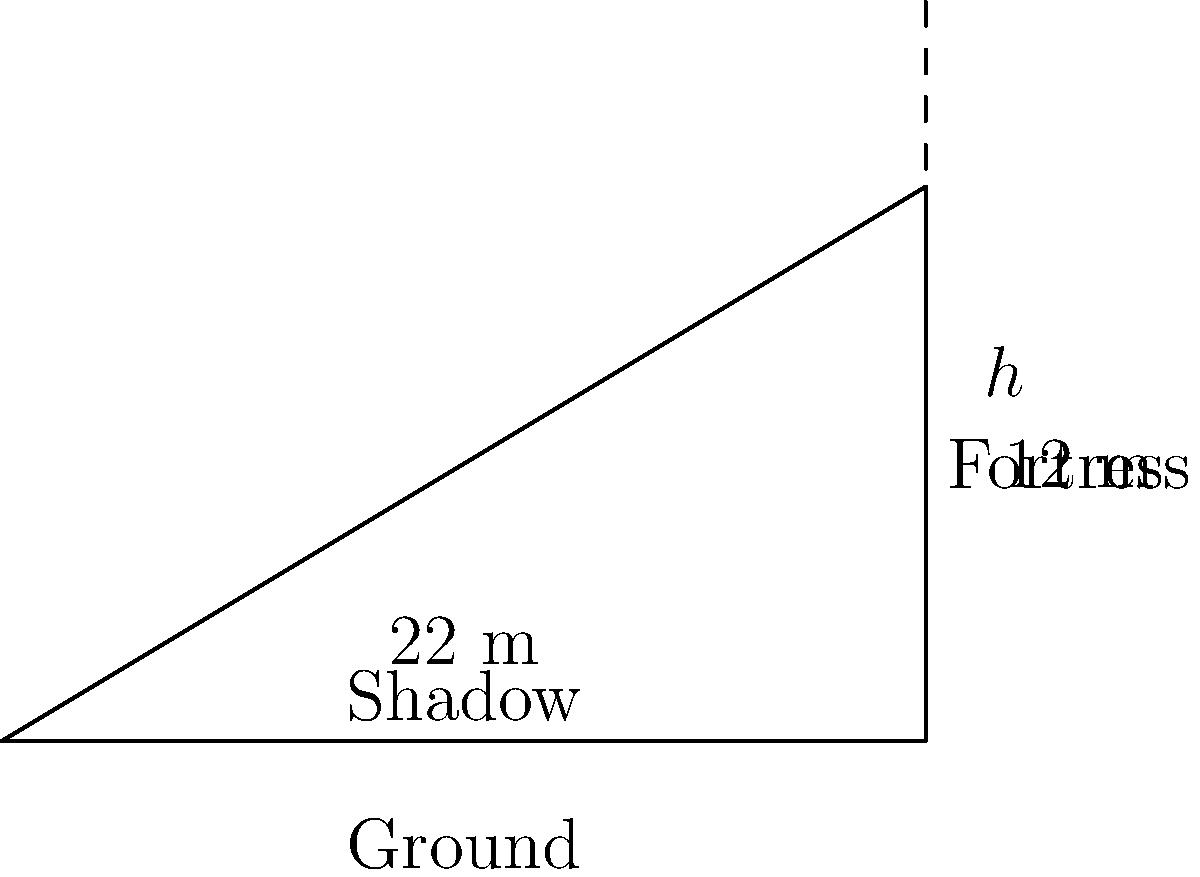At the Golden Temple complex in Amritsar, there stands a historic Sikh fortress. To determine its height without direct measurement, you notice that when the sun's angle of elevation is 30°, the fortress casts a shadow 22 meters long. Using this information and trigonometric ratios, calculate the height of the fortress to the nearest meter. Let's approach this step-by-step using trigonometric ratios:

1) In a right-angled triangle formed by the fortress, its shadow, and the sun's rays, we know:
   - The angle of elevation of the sun is 30°
   - The length of the shadow is 22 meters
   - We need to find the height of the fortress

2) In this scenario, we can use the tangent ratio:
   $\tan \theta = \frac{\text{opposite}}{\text{adjacent}} = \frac{\text{height}}{\text{shadow length}}$

3) We know that $\tan 30° = \frac{1}{\sqrt{3}} \approx 0.577$

4) Let's call the height of the fortress $h$. We can set up the equation:
   $\tan 30° = \frac{h}{22}$

5) Substituting the value of $\tan 30°$:
   $0.577 = \frac{h}{22}$

6) To solve for $h$, multiply both sides by 22:
   $h = 0.577 \times 22 = 12.694$ meters

7) Rounding to the nearest meter:
   $h \approx 13$ meters

Thus, the height of the Sikh fortress is approximately 13 meters.
Answer: 13 meters 